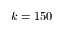Convert formula to latex. <formula><loc_0><loc_0><loc_500><loc_500>k = 1 5 0</formula> 